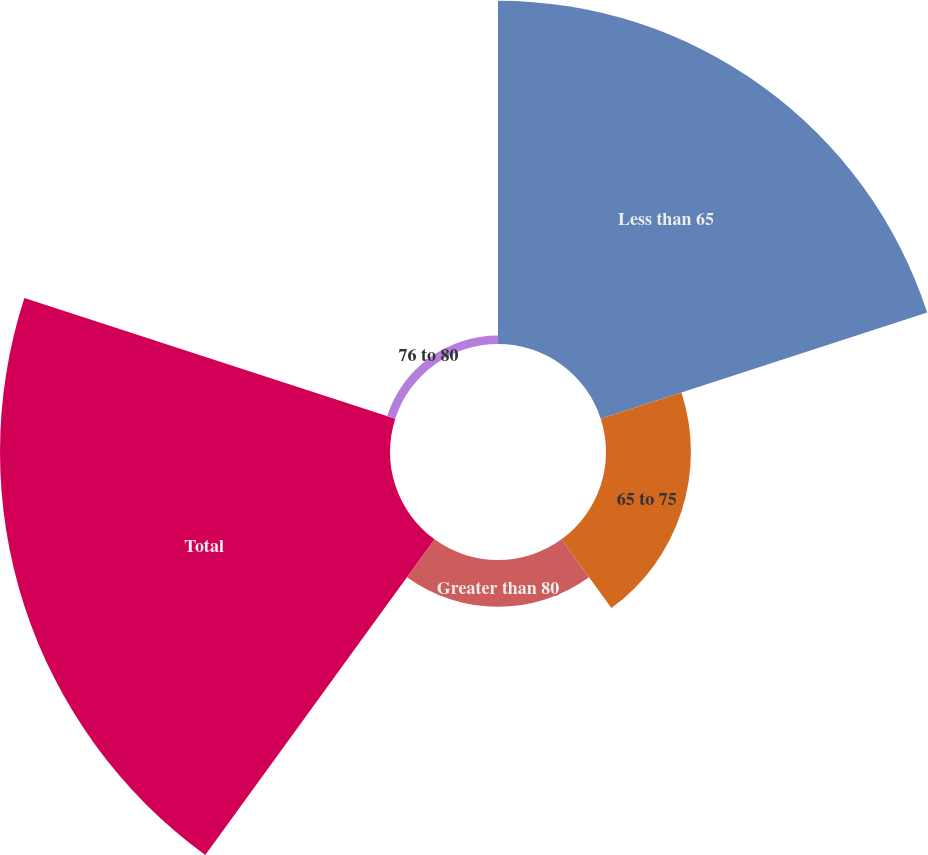<chart> <loc_0><loc_0><loc_500><loc_500><pie_chart><fcel>Less than 65<fcel>65 to 75<fcel>Greater than 80<fcel>Total<fcel>76 to 80<nl><fcel>39.3%<fcel>9.72%<fcel>5.35%<fcel>44.65%<fcel>0.98%<nl></chart> 